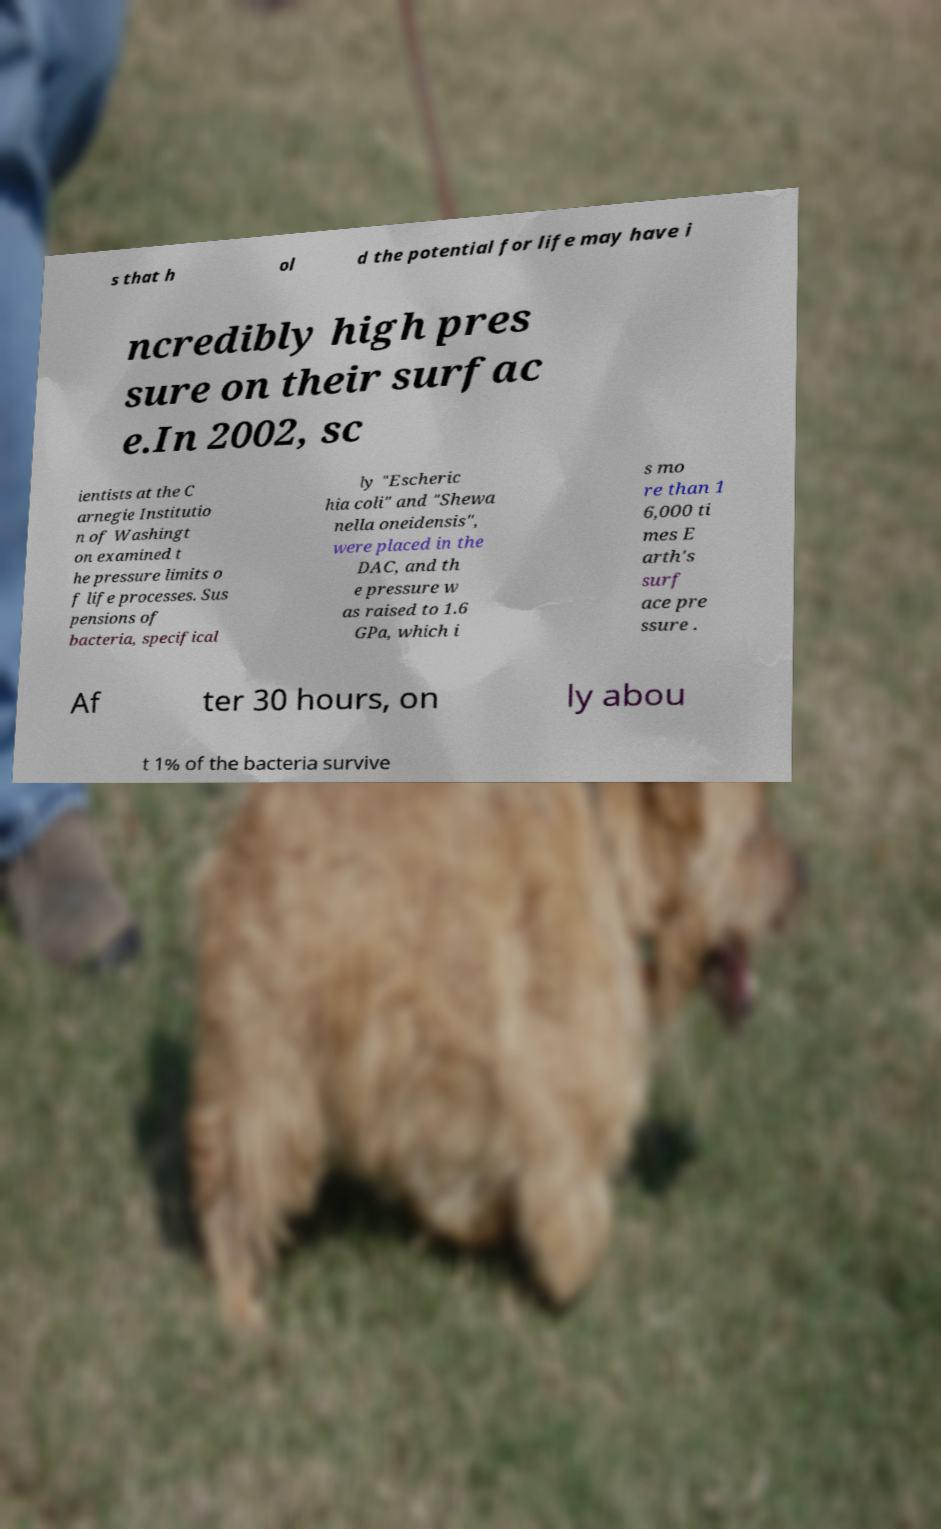There's text embedded in this image that I need extracted. Can you transcribe it verbatim? s that h ol d the potential for life may have i ncredibly high pres sure on their surfac e.In 2002, sc ientists at the C arnegie Institutio n of Washingt on examined t he pressure limits o f life processes. Sus pensions of bacteria, specifical ly "Escheric hia coli" and "Shewa nella oneidensis", were placed in the DAC, and th e pressure w as raised to 1.6 GPa, which i s mo re than 1 6,000 ti mes E arth's surf ace pre ssure . Af ter 30 hours, on ly abou t 1% of the bacteria survive 